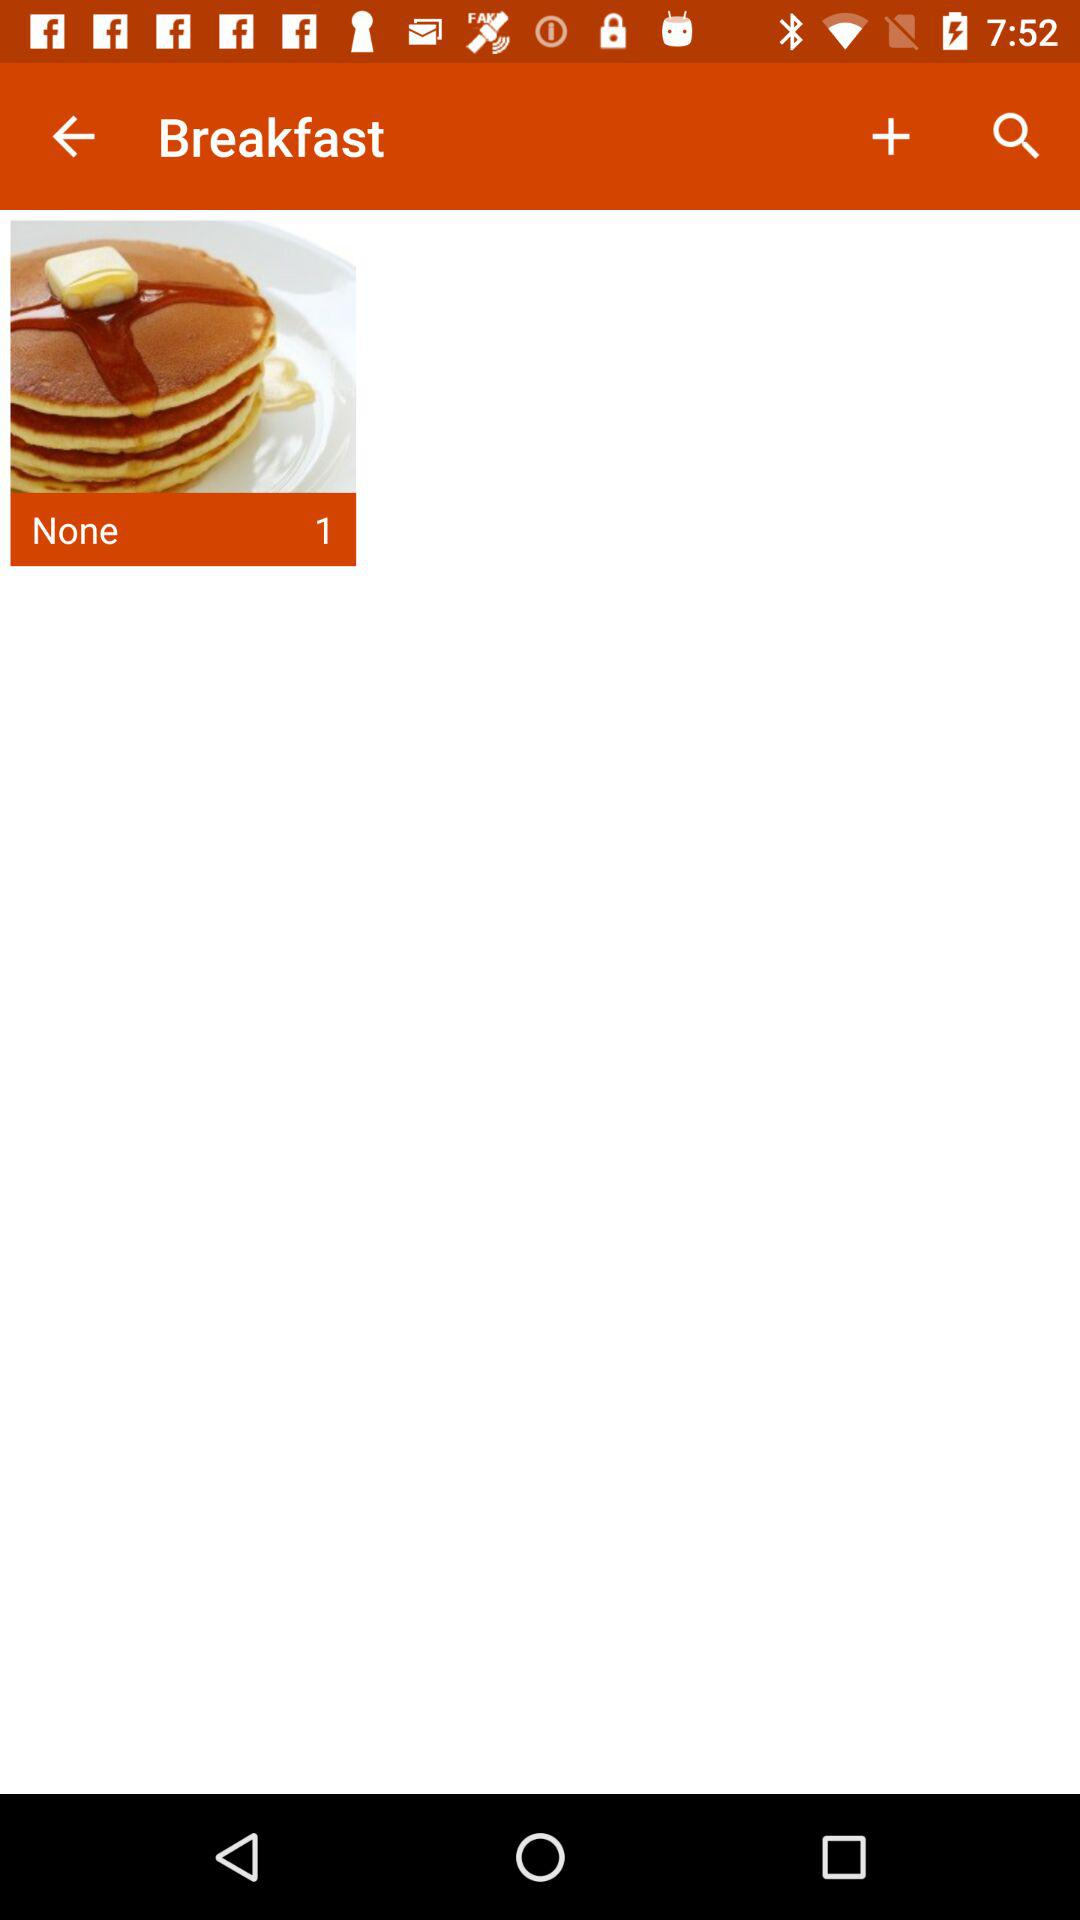How many items are in the "None"? There is 1 item. 